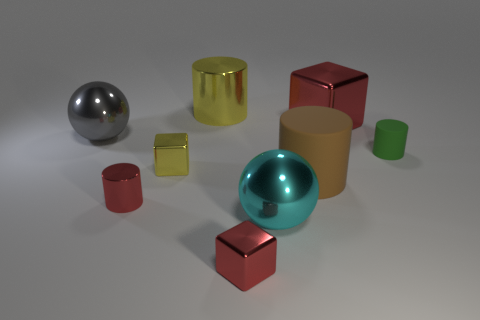Add 1 yellow metallic cylinders. How many objects exist? 10 Subtract all cubes. How many objects are left? 6 Subtract 0 blue balls. How many objects are left? 9 Subtract all green cylinders. Subtract all cyan metallic spheres. How many objects are left? 7 Add 6 yellow things. How many yellow things are left? 8 Add 6 small metallic blocks. How many small metallic blocks exist? 8 